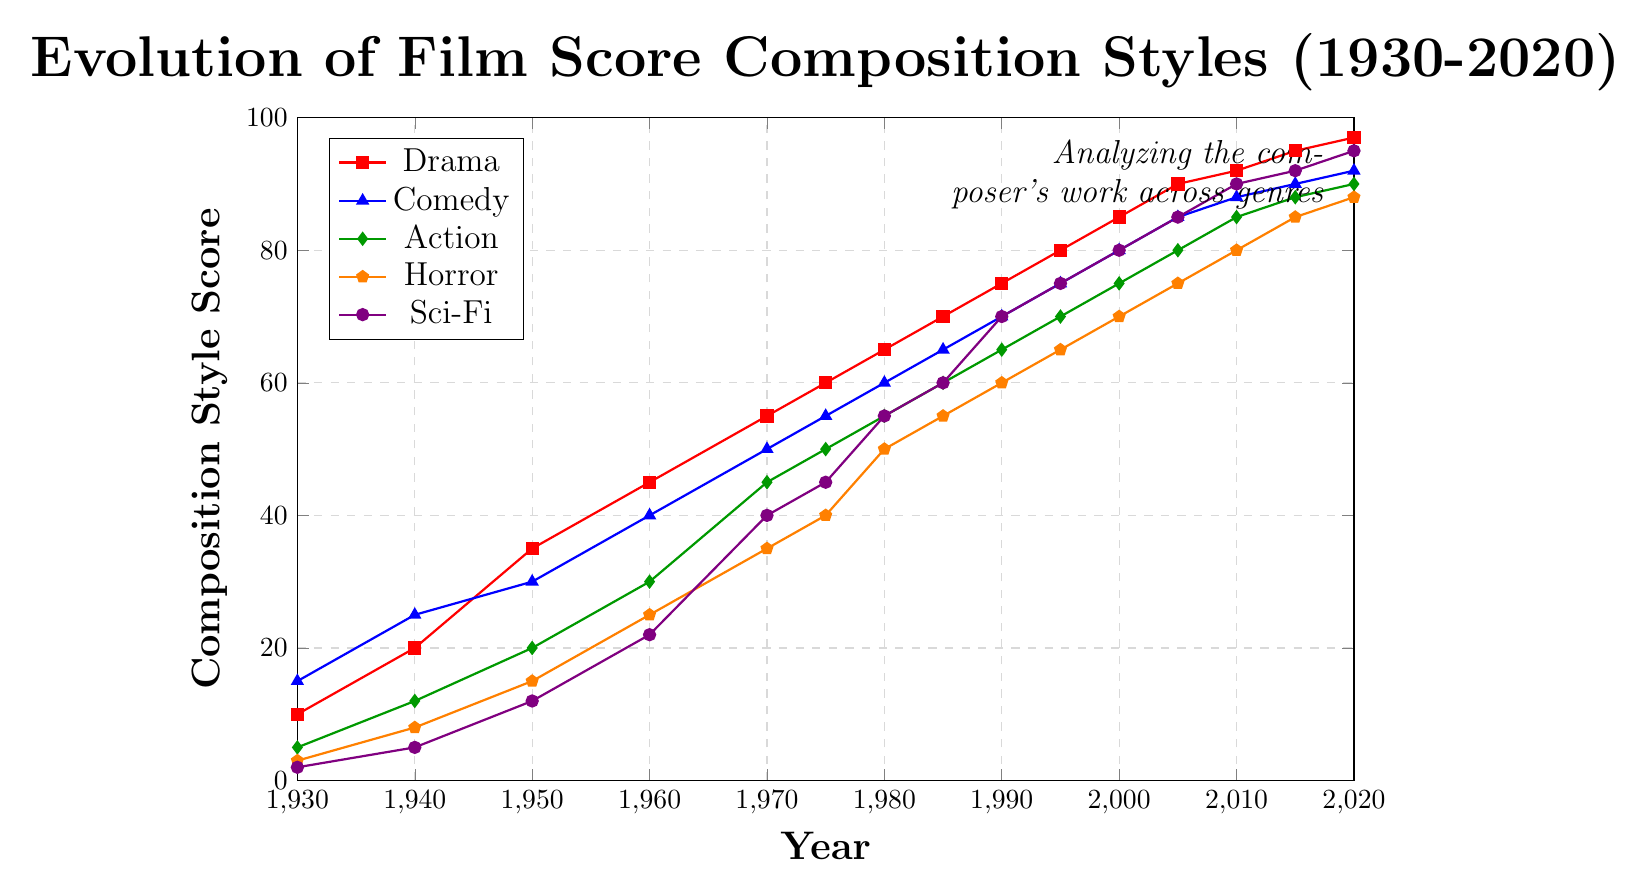What genre shows the steepest increase in composition style score from 1930 to 2020? To determine the steepest increase, we compare the differences between the scores in 2020 and 1930 for each genre. Drama increases by 87 (97-10), Comedy by 77 (92-15), Action by 85 (90-5), Horror by 85 (88-3), and Sci-Fi by 93 (95-2). Hence, Sci-Fi has the steepest increase.
Answer: Sci-Fi Which genre had the highest composition style score in 2005? Look at the scores for each genre in 2005: Drama (90), Comedy (85), Action (80), Horror (75), and Sci-Fi (85). The highest score is Drama, with a score of 90.
Answer: Drama By how much did the composition style score for Horror increase between 1980 and 1995? Subtract the Horror score in 1980 from the Horror score in 1995: 65 - 50 = 15.
Answer: 15 Which genre had the lowest average score over the entire period from 1930 to 2020? Calculate the average score for each genre by summing all the scores between 1930 and 2020 and dividing by the number of data points (15 years): Drama: (10+20+35+45+55+60+65+70+75+80+85+90+92+95+97)/15 = 59.73, Comedy: (15+25+30+40+50+55+60+65+70+75+80+85+88+90+92)/15 = 59.93, Action: (5+12+20+30+45+50+55+60+65+70+75+80+85+88+90)/15 = 54, Horror: (3+8+15+25+35+40+50+55+60+65+70+75+80+85+88)/15 = 49.67, Sci-Fi: (2+5+12+22+40+45+55+60+70+75+80+85+90+92+95)/15 = 55.33. Hence, Horror has the lowest average score.
Answer: Horror What is the average composition style score for Action in the years 1980, 1990, and 2000? Sum the scores for Action in 1980, 1990, and 2000, then divide by 3: (55 + 65 + 75) / 3 = 195 / 3 = 65.
Answer: 65 When did Comedy's composition style score first surpass 50? Review the scores for Comedy across the years. In 1970, the score is 50, and by 1975 it reaches 55.
Answer: 1975 How many genres had a composition style score of at least 90 in 2020? Review the scores in 2020: Drama (97), Comedy (92), Action (90), Horror (88), and Sci-Fi (95). Drama, Comedy, and Sci-Fi have scores of at least 90.
Answer: 3 In which year did Drama's composition style score reach 70 for the first time? Check the scores for Drama over the years: 1985 is the first time the score reaches 70.
Answer: 1985 